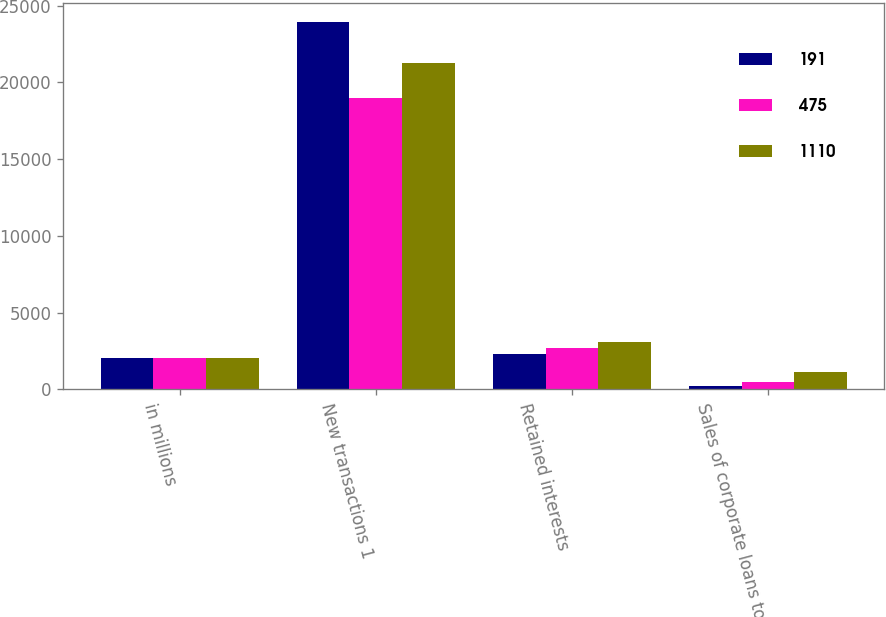Convert chart to OTSL. <chart><loc_0><loc_0><loc_500><loc_500><stacked_bar_chart><ecel><fcel>in millions<fcel>New transactions 1<fcel>Retained interests<fcel>Sales of corporate loans to<nl><fcel>191<fcel>2017<fcel>23939<fcel>2337<fcel>191<nl><fcel>475<fcel>2016<fcel>18975<fcel>2701<fcel>475<nl><fcel>1110<fcel>2015<fcel>21243<fcel>3062<fcel>1110<nl></chart> 